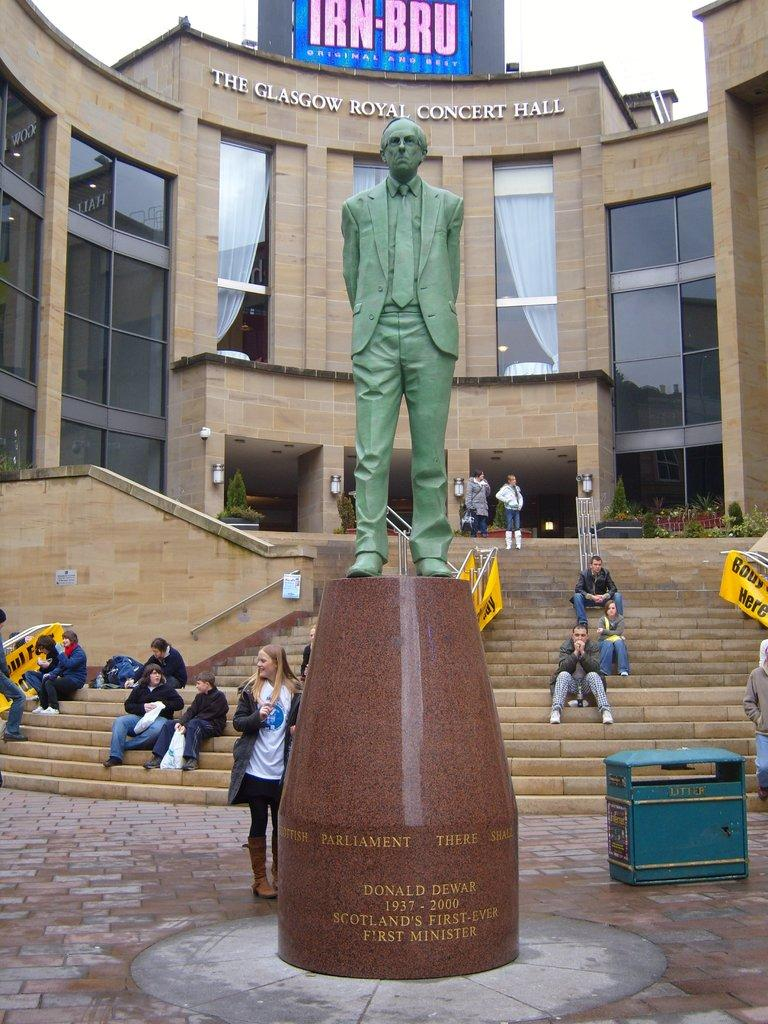What is the main subject in the middle of the image? There is a statue in the middle of the image. What are the people in the image doing? The people in the image are sitting on stairs. What can be seen in the background of the image? There is a building in the background of the image. What is visible at the top of the image? The sky is visible at the top of the image. Can you tell me how many rabbits are hiding behind the statue in the image? There are no rabbits present in the image; it only features a statue, people sitting on stairs, a building in the background, and the sky visible at the top. 